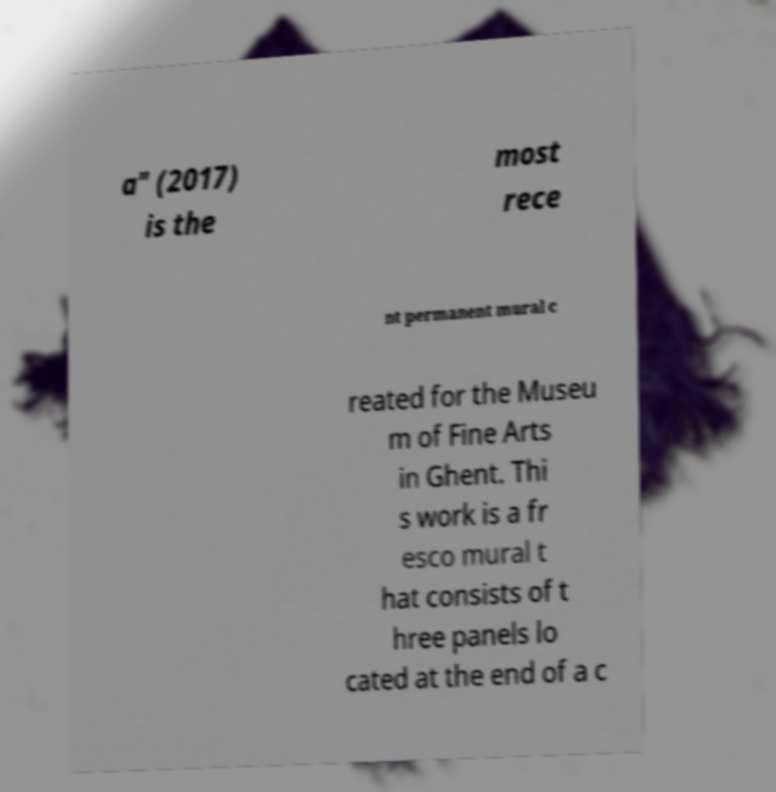Please identify and transcribe the text found in this image. a" (2017) is the most rece nt permanent mural c reated for the Museu m of Fine Arts in Ghent. Thi s work is a fr esco mural t hat consists of t hree panels lo cated at the end of a c 